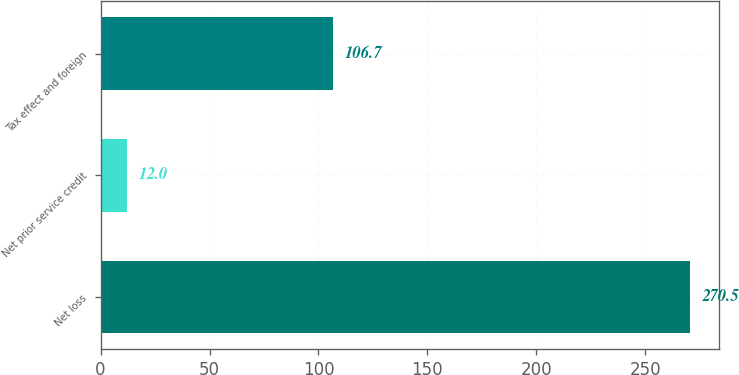<chart> <loc_0><loc_0><loc_500><loc_500><bar_chart><fcel>Net loss<fcel>Net prior service credit<fcel>Tax effect and foreign<nl><fcel>270.5<fcel>12<fcel>106.7<nl></chart> 